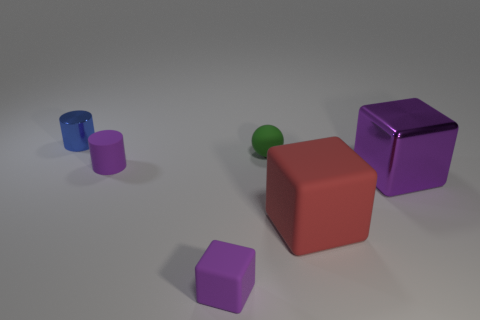Is the color of the small matte cube the same as the tiny rubber cylinder?
Provide a succinct answer. Yes. What is the material of the red thing?
Your answer should be very brief. Rubber. Are any things visible?
Keep it short and to the point. Yes. Are there the same number of objects that are behind the blue metallic cylinder and purple cylinders?
Your answer should be very brief. No. Is there any other thing that is made of the same material as the tiny purple block?
Your answer should be compact. Yes. How many small things are red blocks or cyan rubber cylinders?
Keep it short and to the point. 0. There is a small rubber object that is the same color as the matte cylinder; what is its shape?
Provide a short and direct response. Cube. Is the purple object that is on the right side of the large red cube made of the same material as the tiny blue object?
Give a very brief answer. Yes. What is the material of the big red block behind the small purple rubber thing in front of the large purple object?
Your answer should be compact. Rubber. What number of tiny purple things have the same shape as the big purple thing?
Offer a terse response. 1. 